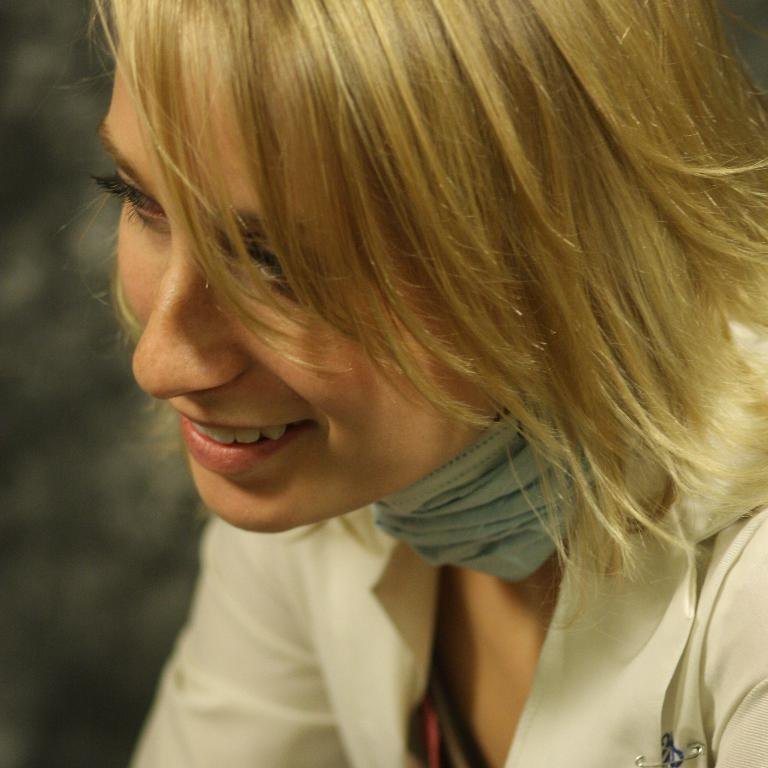Who is present in the image? There is a woman in the image. What expression does the woman have? The woman is smiling. What news is the woman reading in the image? There is no news or any reading material present in the image; it only shows a woman smiling. 